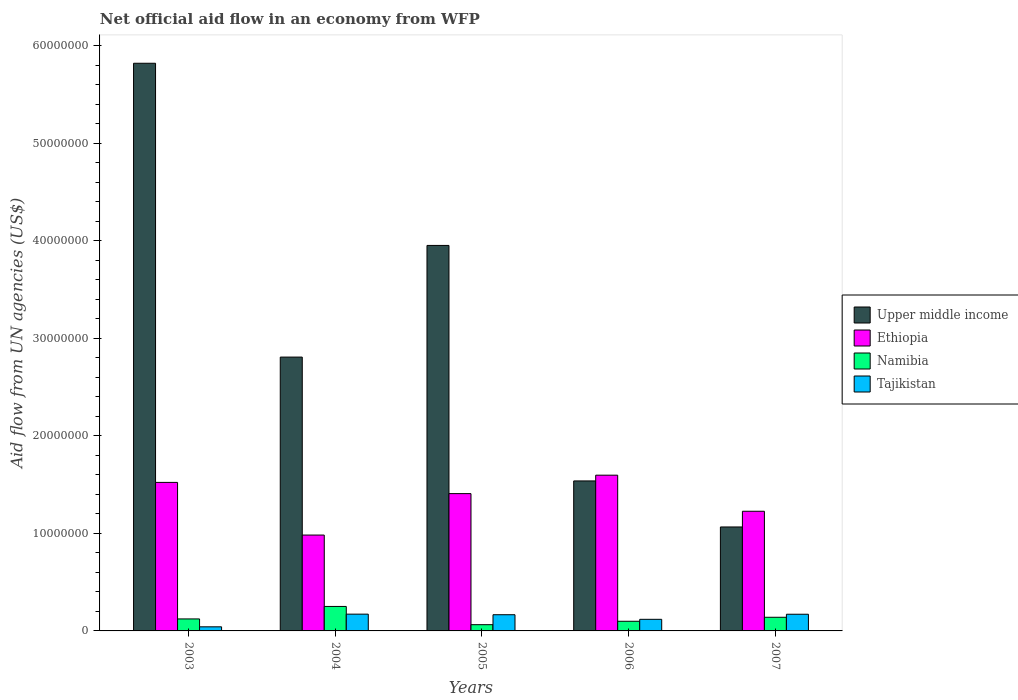Are the number of bars per tick equal to the number of legend labels?
Your answer should be compact. Yes. Are the number of bars on each tick of the X-axis equal?
Your response must be concise. Yes. How many bars are there on the 4th tick from the left?
Provide a succinct answer. 4. How many bars are there on the 2nd tick from the right?
Your answer should be compact. 4. What is the net official aid flow in Tajikistan in 2003?
Provide a short and direct response. 4.20e+05. Across all years, what is the maximum net official aid flow in Upper middle income?
Offer a terse response. 5.82e+07. Across all years, what is the minimum net official aid flow in Upper middle income?
Provide a succinct answer. 1.07e+07. In which year was the net official aid flow in Upper middle income minimum?
Make the answer very short. 2007. What is the total net official aid flow in Tajikistan in the graph?
Provide a succinct answer. 6.70e+06. What is the difference between the net official aid flow in Tajikistan in 2003 and that in 2007?
Your response must be concise. -1.29e+06. What is the difference between the net official aid flow in Upper middle income in 2003 and the net official aid flow in Tajikistan in 2005?
Your response must be concise. 5.66e+07. What is the average net official aid flow in Tajikistan per year?
Your response must be concise. 1.34e+06. In the year 2003, what is the difference between the net official aid flow in Tajikistan and net official aid flow in Ethiopia?
Give a very brief answer. -1.48e+07. What is the ratio of the net official aid flow in Namibia in 2004 to that in 2007?
Your answer should be very brief. 1.79. Is the net official aid flow in Ethiopia in 2005 less than that in 2007?
Your answer should be compact. No. Is the difference between the net official aid flow in Tajikistan in 2005 and 2007 greater than the difference between the net official aid flow in Ethiopia in 2005 and 2007?
Your answer should be very brief. No. What is the difference between the highest and the second highest net official aid flow in Ethiopia?
Your answer should be very brief. 7.40e+05. What is the difference between the highest and the lowest net official aid flow in Tajikistan?
Your answer should be compact. 1.30e+06. In how many years, is the net official aid flow in Upper middle income greater than the average net official aid flow in Upper middle income taken over all years?
Provide a succinct answer. 2. Is the sum of the net official aid flow in Namibia in 2005 and 2006 greater than the maximum net official aid flow in Ethiopia across all years?
Provide a succinct answer. No. Is it the case that in every year, the sum of the net official aid flow in Upper middle income and net official aid flow in Tajikistan is greater than the sum of net official aid flow in Ethiopia and net official aid flow in Namibia?
Keep it short and to the point. No. What does the 1st bar from the left in 2007 represents?
Ensure brevity in your answer.  Upper middle income. What does the 1st bar from the right in 2005 represents?
Your response must be concise. Tajikistan. How many bars are there?
Your response must be concise. 20. Does the graph contain any zero values?
Make the answer very short. No. How are the legend labels stacked?
Give a very brief answer. Vertical. What is the title of the graph?
Your response must be concise. Net official aid flow in an economy from WFP. Does "South Africa" appear as one of the legend labels in the graph?
Your response must be concise. No. What is the label or title of the X-axis?
Offer a terse response. Years. What is the label or title of the Y-axis?
Offer a terse response. Aid flow from UN agencies (US$). What is the Aid flow from UN agencies (US$) of Upper middle income in 2003?
Your answer should be compact. 5.82e+07. What is the Aid flow from UN agencies (US$) of Ethiopia in 2003?
Give a very brief answer. 1.52e+07. What is the Aid flow from UN agencies (US$) of Namibia in 2003?
Provide a succinct answer. 1.23e+06. What is the Aid flow from UN agencies (US$) in Upper middle income in 2004?
Your response must be concise. 2.81e+07. What is the Aid flow from UN agencies (US$) in Ethiopia in 2004?
Make the answer very short. 9.83e+06. What is the Aid flow from UN agencies (US$) of Namibia in 2004?
Provide a succinct answer. 2.51e+06. What is the Aid flow from UN agencies (US$) in Tajikistan in 2004?
Offer a terse response. 1.72e+06. What is the Aid flow from UN agencies (US$) of Upper middle income in 2005?
Offer a very short reply. 3.95e+07. What is the Aid flow from UN agencies (US$) of Ethiopia in 2005?
Make the answer very short. 1.41e+07. What is the Aid flow from UN agencies (US$) in Namibia in 2005?
Make the answer very short. 6.40e+05. What is the Aid flow from UN agencies (US$) of Tajikistan in 2005?
Your response must be concise. 1.66e+06. What is the Aid flow from UN agencies (US$) in Upper middle income in 2006?
Your response must be concise. 1.54e+07. What is the Aid flow from UN agencies (US$) in Ethiopia in 2006?
Your answer should be compact. 1.60e+07. What is the Aid flow from UN agencies (US$) in Namibia in 2006?
Provide a succinct answer. 9.90e+05. What is the Aid flow from UN agencies (US$) of Tajikistan in 2006?
Provide a succinct answer. 1.19e+06. What is the Aid flow from UN agencies (US$) of Upper middle income in 2007?
Ensure brevity in your answer.  1.07e+07. What is the Aid flow from UN agencies (US$) in Ethiopia in 2007?
Make the answer very short. 1.23e+07. What is the Aid flow from UN agencies (US$) in Namibia in 2007?
Your answer should be very brief. 1.40e+06. What is the Aid flow from UN agencies (US$) in Tajikistan in 2007?
Provide a succinct answer. 1.71e+06. Across all years, what is the maximum Aid flow from UN agencies (US$) of Upper middle income?
Ensure brevity in your answer.  5.82e+07. Across all years, what is the maximum Aid flow from UN agencies (US$) of Ethiopia?
Provide a short and direct response. 1.60e+07. Across all years, what is the maximum Aid flow from UN agencies (US$) in Namibia?
Make the answer very short. 2.51e+06. Across all years, what is the maximum Aid flow from UN agencies (US$) of Tajikistan?
Your response must be concise. 1.72e+06. Across all years, what is the minimum Aid flow from UN agencies (US$) in Upper middle income?
Give a very brief answer. 1.07e+07. Across all years, what is the minimum Aid flow from UN agencies (US$) in Ethiopia?
Keep it short and to the point. 9.83e+06. Across all years, what is the minimum Aid flow from UN agencies (US$) in Namibia?
Provide a succinct answer. 6.40e+05. What is the total Aid flow from UN agencies (US$) in Upper middle income in the graph?
Offer a very short reply. 1.52e+08. What is the total Aid flow from UN agencies (US$) of Ethiopia in the graph?
Offer a terse response. 6.74e+07. What is the total Aid flow from UN agencies (US$) of Namibia in the graph?
Make the answer very short. 6.77e+06. What is the total Aid flow from UN agencies (US$) of Tajikistan in the graph?
Offer a terse response. 6.70e+06. What is the difference between the Aid flow from UN agencies (US$) in Upper middle income in 2003 and that in 2004?
Your answer should be very brief. 3.01e+07. What is the difference between the Aid flow from UN agencies (US$) in Ethiopia in 2003 and that in 2004?
Provide a short and direct response. 5.40e+06. What is the difference between the Aid flow from UN agencies (US$) of Namibia in 2003 and that in 2004?
Offer a terse response. -1.28e+06. What is the difference between the Aid flow from UN agencies (US$) of Tajikistan in 2003 and that in 2004?
Make the answer very short. -1.30e+06. What is the difference between the Aid flow from UN agencies (US$) in Upper middle income in 2003 and that in 2005?
Make the answer very short. 1.87e+07. What is the difference between the Aid flow from UN agencies (US$) of Ethiopia in 2003 and that in 2005?
Your answer should be compact. 1.15e+06. What is the difference between the Aid flow from UN agencies (US$) of Namibia in 2003 and that in 2005?
Offer a very short reply. 5.90e+05. What is the difference between the Aid flow from UN agencies (US$) in Tajikistan in 2003 and that in 2005?
Offer a terse response. -1.24e+06. What is the difference between the Aid flow from UN agencies (US$) in Upper middle income in 2003 and that in 2006?
Offer a terse response. 4.28e+07. What is the difference between the Aid flow from UN agencies (US$) in Ethiopia in 2003 and that in 2006?
Your response must be concise. -7.40e+05. What is the difference between the Aid flow from UN agencies (US$) in Namibia in 2003 and that in 2006?
Offer a terse response. 2.40e+05. What is the difference between the Aid flow from UN agencies (US$) of Tajikistan in 2003 and that in 2006?
Offer a terse response. -7.70e+05. What is the difference between the Aid flow from UN agencies (US$) in Upper middle income in 2003 and that in 2007?
Provide a short and direct response. 4.76e+07. What is the difference between the Aid flow from UN agencies (US$) in Ethiopia in 2003 and that in 2007?
Make the answer very short. 2.96e+06. What is the difference between the Aid flow from UN agencies (US$) of Namibia in 2003 and that in 2007?
Keep it short and to the point. -1.70e+05. What is the difference between the Aid flow from UN agencies (US$) of Tajikistan in 2003 and that in 2007?
Provide a short and direct response. -1.29e+06. What is the difference between the Aid flow from UN agencies (US$) of Upper middle income in 2004 and that in 2005?
Provide a short and direct response. -1.14e+07. What is the difference between the Aid flow from UN agencies (US$) of Ethiopia in 2004 and that in 2005?
Make the answer very short. -4.25e+06. What is the difference between the Aid flow from UN agencies (US$) in Namibia in 2004 and that in 2005?
Your answer should be very brief. 1.87e+06. What is the difference between the Aid flow from UN agencies (US$) in Upper middle income in 2004 and that in 2006?
Give a very brief answer. 1.27e+07. What is the difference between the Aid flow from UN agencies (US$) in Ethiopia in 2004 and that in 2006?
Offer a terse response. -6.14e+06. What is the difference between the Aid flow from UN agencies (US$) in Namibia in 2004 and that in 2006?
Your answer should be compact. 1.52e+06. What is the difference between the Aid flow from UN agencies (US$) of Tajikistan in 2004 and that in 2006?
Your answer should be very brief. 5.30e+05. What is the difference between the Aid flow from UN agencies (US$) in Upper middle income in 2004 and that in 2007?
Your response must be concise. 1.74e+07. What is the difference between the Aid flow from UN agencies (US$) of Ethiopia in 2004 and that in 2007?
Your response must be concise. -2.44e+06. What is the difference between the Aid flow from UN agencies (US$) in Namibia in 2004 and that in 2007?
Keep it short and to the point. 1.11e+06. What is the difference between the Aid flow from UN agencies (US$) in Upper middle income in 2005 and that in 2006?
Offer a very short reply. 2.42e+07. What is the difference between the Aid flow from UN agencies (US$) in Ethiopia in 2005 and that in 2006?
Offer a terse response. -1.89e+06. What is the difference between the Aid flow from UN agencies (US$) of Namibia in 2005 and that in 2006?
Provide a short and direct response. -3.50e+05. What is the difference between the Aid flow from UN agencies (US$) in Tajikistan in 2005 and that in 2006?
Your answer should be compact. 4.70e+05. What is the difference between the Aid flow from UN agencies (US$) of Upper middle income in 2005 and that in 2007?
Your response must be concise. 2.89e+07. What is the difference between the Aid flow from UN agencies (US$) of Ethiopia in 2005 and that in 2007?
Provide a succinct answer. 1.81e+06. What is the difference between the Aid flow from UN agencies (US$) of Namibia in 2005 and that in 2007?
Your answer should be very brief. -7.60e+05. What is the difference between the Aid flow from UN agencies (US$) in Tajikistan in 2005 and that in 2007?
Your answer should be very brief. -5.00e+04. What is the difference between the Aid flow from UN agencies (US$) in Upper middle income in 2006 and that in 2007?
Provide a short and direct response. 4.72e+06. What is the difference between the Aid flow from UN agencies (US$) of Ethiopia in 2006 and that in 2007?
Provide a succinct answer. 3.70e+06. What is the difference between the Aid flow from UN agencies (US$) of Namibia in 2006 and that in 2007?
Provide a short and direct response. -4.10e+05. What is the difference between the Aid flow from UN agencies (US$) of Tajikistan in 2006 and that in 2007?
Make the answer very short. -5.20e+05. What is the difference between the Aid flow from UN agencies (US$) of Upper middle income in 2003 and the Aid flow from UN agencies (US$) of Ethiopia in 2004?
Offer a very short reply. 4.84e+07. What is the difference between the Aid flow from UN agencies (US$) of Upper middle income in 2003 and the Aid flow from UN agencies (US$) of Namibia in 2004?
Give a very brief answer. 5.57e+07. What is the difference between the Aid flow from UN agencies (US$) in Upper middle income in 2003 and the Aid flow from UN agencies (US$) in Tajikistan in 2004?
Provide a succinct answer. 5.65e+07. What is the difference between the Aid flow from UN agencies (US$) in Ethiopia in 2003 and the Aid flow from UN agencies (US$) in Namibia in 2004?
Give a very brief answer. 1.27e+07. What is the difference between the Aid flow from UN agencies (US$) in Ethiopia in 2003 and the Aid flow from UN agencies (US$) in Tajikistan in 2004?
Keep it short and to the point. 1.35e+07. What is the difference between the Aid flow from UN agencies (US$) in Namibia in 2003 and the Aid flow from UN agencies (US$) in Tajikistan in 2004?
Give a very brief answer. -4.90e+05. What is the difference between the Aid flow from UN agencies (US$) of Upper middle income in 2003 and the Aid flow from UN agencies (US$) of Ethiopia in 2005?
Your answer should be very brief. 4.41e+07. What is the difference between the Aid flow from UN agencies (US$) in Upper middle income in 2003 and the Aid flow from UN agencies (US$) in Namibia in 2005?
Offer a very short reply. 5.76e+07. What is the difference between the Aid flow from UN agencies (US$) of Upper middle income in 2003 and the Aid flow from UN agencies (US$) of Tajikistan in 2005?
Your answer should be compact. 5.66e+07. What is the difference between the Aid flow from UN agencies (US$) of Ethiopia in 2003 and the Aid flow from UN agencies (US$) of Namibia in 2005?
Ensure brevity in your answer.  1.46e+07. What is the difference between the Aid flow from UN agencies (US$) of Ethiopia in 2003 and the Aid flow from UN agencies (US$) of Tajikistan in 2005?
Offer a terse response. 1.36e+07. What is the difference between the Aid flow from UN agencies (US$) in Namibia in 2003 and the Aid flow from UN agencies (US$) in Tajikistan in 2005?
Make the answer very short. -4.30e+05. What is the difference between the Aid flow from UN agencies (US$) of Upper middle income in 2003 and the Aid flow from UN agencies (US$) of Ethiopia in 2006?
Provide a short and direct response. 4.22e+07. What is the difference between the Aid flow from UN agencies (US$) in Upper middle income in 2003 and the Aid flow from UN agencies (US$) in Namibia in 2006?
Make the answer very short. 5.72e+07. What is the difference between the Aid flow from UN agencies (US$) in Upper middle income in 2003 and the Aid flow from UN agencies (US$) in Tajikistan in 2006?
Offer a terse response. 5.70e+07. What is the difference between the Aid flow from UN agencies (US$) of Ethiopia in 2003 and the Aid flow from UN agencies (US$) of Namibia in 2006?
Your answer should be compact. 1.42e+07. What is the difference between the Aid flow from UN agencies (US$) in Ethiopia in 2003 and the Aid flow from UN agencies (US$) in Tajikistan in 2006?
Offer a terse response. 1.40e+07. What is the difference between the Aid flow from UN agencies (US$) in Namibia in 2003 and the Aid flow from UN agencies (US$) in Tajikistan in 2006?
Give a very brief answer. 4.00e+04. What is the difference between the Aid flow from UN agencies (US$) in Upper middle income in 2003 and the Aid flow from UN agencies (US$) in Ethiopia in 2007?
Provide a short and direct response. 4.59e+07. What is the difference between the Aid flow from UN agencies (US$) of Upper middle income in 2003 and the Aid flow from UN agencies (US$) of Namibia in 2007?
Provide a succinct answer. 5.68e+07. What is the difference between the Aid flow from UN agencies (US$) of Upper middle income in 2003 and the Aid flow from UN agencies (US$) of Tajikistan in 2007?
Make the answer very short. 5.65e+07. What is the difference between the Aid flow from UN agencies (US$) in Ethiopia in 2003 and the Aid flow from UN agencies (US$) in Namibia in 2007?
Give a very brief answer. 1.38e+07. What is the difference between the Aid flow from UN agencies (US$) of Ethiopia in 2003 and the Aid flow from UN agencies (US$) of Tajikistan in 2007?
Provide a succinct answer. 1.35e+07. What is the difference between the Aid flow from UN agencies (US$) in Namibia in 2003 and the Aid flow from UN agencies (US$) in Tajikistan in 2007?
Your answer should be very brief. -4.80e+05. What is the difference between the Aid flow from UN agencies (US$) in Upper middle income in 2004 and the Aid flow from UN agencies (US$) in Ethiopia in 2005?
Offer a very short reply. 1.40e+07. What is the difference between the Aid flow from UN agencies (US$) of Upper middle income in 2004 and the Aid flow from UN agencies (US$) of Namibia in 2005?
Offer a terse response. 2.74e+07. What is the difference between the Aid flow from UN agencies (US$) of Upper middle income in 2004 and the Aid flow from UN agencies (US$) of Tajikistan in 2005?
Give a very brief answer. 2.64e+07. What is the difference between the Aid flow from UN agencies (US$) in Ethiopia in 2004 and the Aid flow from UN agencies (US$) in Namibia in 2005?
Make the answer very short. 9.19e+06. What is the difference between the Aid flow from UN agencies (US$) in Ethiopia in 2004 and the Aid flow from UN agencies (US$) in Tajikistan in 2005?
Ensure brevity in your answer.  8.17e+06. What is the difference between the Aid flow from UN agencies (US$) of Namibia in 2004 and the Aid flow from UN agencies (US$) of Tajikistan in 2005?
Provide a succinct answer. 8.50e+05. What is the difference between the Aid flow from UN agencies (US$) in Upper middle income in 2004 and the Aid flow from UN agencies (US$) in Ethiopia in 2006?
Offer a terse response. 1.21e+07. What is the difference between the Aid flow from UN agencies (US$) in Upper middle income in 2004 and the Aid flow from UN agencies (US$) in Namibia in 2006?
Provide a short and direct response. 2.71e+07. What is the difference between the Aid flow from UN agencies (US$) of Upper middle income in 2004 and the Aid flow from UN agencies (US$) of Tajikistan in 2006?
Your response must be concise. 2.69e+07. What is the difference between the Aid flow from UN agencies (US$) in Ethiopia in 2004 and the Aid flow from UN agencies (US$) in Namibia in 2006?
Ensure brevity in your answer.  8.84e+06. What is the difference between the Aid flow from UN agencies (US$) in Ethiopia in 2004 and the Aid flow from UN agencies (US$) in Tajikistan in 2006?
Give a very brief answer. 8.64e+06. What is the difference between the Aid flow from UN agencies (US$) of Namibia in 2004 and the Aid flow from UN agencies (US$) of Tajikistan in 2006?
Make the answer very short. 1.32e+06. What is the difference between the Aid flow from UN agencies (US$) in Upper middle income in 2004 and the Aid flow from UN agencies (US$) in Ethiopia in 2007?
Provide a succinct answer. 1.58e+07. What is the difference between the Aid flow from UN agencies (US$) in Upper middle income in 2004 and the Aid flow from UN agencies (US$) in Namibia in 2007?
Give a very brief answer. 2.67e+07. What is the difference between the Aid flow from UN agencies (US$) of Upper middle income in 2004 and the Aid flow from UN agencies (US$) of Tajikistan in 2007?
Provide a short and direct response. 2.64e+07. What is the difference between the Aid flow from UN agencies (US$) of Ethiopia in 2004 and the Aid flow from UN agencies (US$) of Namibia in 2007?
Keep it short and to the point. 8.43e+06. What is the difference between the Aid flow from UN agencies (US$) of Ethiopia in 2004 and the Aid flow from UN agencies (US$) of Tajikistan in 2007?
Provide a short and direct response. 8.12e+06. What is the difference between the Aid flow from UN agencies (US$) in Namibia in 2004 and the Aid flow from UN agencies (US$) in Tajikistan in 2007?
Ensure brevity in your answer.  8.00e+05. What is the difference between the Aid flow from UN agencies (US$) of Upper middle income in 2005 and the Aid flow from UN agencies (US$) of Ethiopia in 2006?
Your answer should be compact. 2.36e+07. What is the difference between the Aid flow from UN agencies (US$) of Upper middle income in 2005 and the Aid flow from UN agencies (US$) of Namibia in 2006?
Give a very brief answer. 3.85e+07. What is the difference between the Aid flow from UN agencies (US$) of Upper middle income in 2005 and the Aid flow from UN agencies (US$) of Tajikistan in 2006?
Provide a succinct answer. 3.83e+07. What is the difference between the Aid flow from UN agencies (US$) in Ethiopia in 2005 and the Aid flow from UN agencies (US$) in Namibia in 2006?
Your answer should be compact. 1.31e+07. What is the difference between the Aid flow from UN agencies (US$) in Ethiopia in 2005 and the Aid flow from UN agencies (US$) in Tajikistan in 2006?
Your response must be concise. 1.29e+07. What is the difference between the Aid flow from UN agencies (US$) of Namibia in 2005 and the Aid flow from UN agencies (US$) of Tajikistan in 2006?
Make the answer very short. -5.50e+05. What is the difference between the Aid flow from UN agencies (US$) of Upper middle income in 2005 and the Aid flow from UN agencies (US$) of Ethiopia in 2007?
Ensure brevity in your answer.  2.73e+07. What is the difference between the Aid flow from UN agencies (US$) in Upper middle income in 2005 and the Aid flow from UN agencies (US$) in Namibia in 2007?
Your response must be concise. 3.81e+07. What is the difference between the Aid flow from UN agencies (US$) of Upper middle income in 2005 and the Aid flow from UN agencies (US$) of Tajikistan in 2007?
Ensure brevity in your answer.  3.78e+07. What is the difference between the Aid flow from UN agencies (US$) in Ethiopia in 2005 and the Aid flow from UN agencies (US$) in Namibia in 2007?
Your answer should be very brief. 1.27e+07. What is the difference between the Aid flow from UN agencies (US$) in Ethiopia in 2005 and the Aid flow from UN agencies (US$) in Tajikistan in 2007?
Your answer should be compact. 1.24e+07. What is the difference between the Aid flow from UN agencies (US$) in Namibia in 2005 and the Aid flow from UN agencies (US$) in Tajikistan in 2007?
Your answer should be compact. -1.07e+06. What is the difference between the Aid flow from UN agencies (US$) in Upper middle income in 2006 and the Aid flow from UN agencies (US$) in Ethiopia in 2007?
Ensure brevity in your answer.  3.11e+06. What is the difference between the Aid flow from UN agencies (US$) in Upper middle income in 2006 and the Aid flow from UN agencies (US$) in Namibia in 2007?
Provide a short and direct response. 1.40e+07. What is the difference between the Aid flow from UN agencies (US$) of Upper middle income in 2006 and the Aid flow from UN agencies (US$) of Tajikistan in 2007?
Keep it short and to the point. 1.37e+07. What is the difference between the Aid flow from UN agencies (US$) in Ethiopia in 2006 and the Aid flow from UN agencies (US$) in Namibia in 2007?
Offer a terse response. 1.46e+07. What is the difference between the Aid flow from UN agencies (US$) of Ethiopia in 2006 and the Aid flow from UN agencies (US$) of Tajikistan in 2007?
Your answer should be compact. 1.43e+07. What is the difference between the Aid flow from UN agencies (US$) in Namibia in 2006 and the Aid flow from UN agencies (US$) in Tajikistan in 2007?
Offer a very short reply. -7.20e+05. What is the average Aid flow from UN agencies (US$) in Upper middle income per year?
Keep it short and to the point. 3.04e+07. What is the average Aid flow from UN agencies (US$) of Ethiopia per year?
Provide a short and direct response. 1.35e+07. What is the average Aid flow from UN agencies (US$) of Namibia per year?
Ensure brevity in your answer.  1.35e+06. What is the average Aid flow from UN agencies (US$) in Tajikistan per year?
Keep it short and to the point. 1.34e+06. In the year 2003, what is the difference between the Aid flow from UN agencies (US$) of Upper middle income and Aid flow from UN agencies (US$) of Ethiopia?
Ensure brevity in your answer.  4.30e+07. In the year 2003, what is the difference between the Aid flow from UN agencies (US$) of Upper middle income and Aid flow from UN agencies (US$) of Namibia?
Your response must be concise. 5.70e+07. In the year 2003, what is the difference between the Aid flow from UN agencies (US$) of Upper middle income and Aid flow from UN agencies (US$) of Tajikistan?
Your response must be concise. 5.78e+07. In the year 2003, what is the difference between the Aid flow from UN agencies (US$) of Ethiopia and Aid flow from UN agencies (US$) of Namibia?
Give a very brief answer. 1.40e+07. In the year 2003, what is the difference between the Aid flow from UN agencies (US$) in Ethiopia and Aid flow from UN agencies (US$) in Tajikistan?
Offer a very short reply. 1.48e+07. In the year 2003, what is the difference between the Aid flow from UN agencies (US$) of Namibia and Aid flow from UN agencies (US$) of Tajikistan?
Your response must be concise. 8.10e+05. In the year 2004, what is the difference between the Aid flow from UN agencies (US$) of Upper middle income and Aid flow from UN agencies (US$) of Ethiopia?
Your answer should be very brief. 1.82e+07. In the year 2004, what is the difference between the Aid flow from UN agencies (US$) in Upper middle income and Aid flow from UN agencies (US$) in Namibia?
Provide a short and direct response. 2.56e+07. In the year 2004, what is the difference between the Aid flow from UN agencies (US$) in Upper middle income and Aid flow from UN agencies (US$) in Tajikistan?
Give a very brief answer. 2.64e+07. In the year 2004, what is the difference between the Aid flow from UN agencies (US$) in Ethiopia and Aid flow from UN agencies (US$) in Namibia?
Keep it short and to the point. 7.32e+06. In the year 2004, what is the difference between the Aid flow from UN agencies (US$) of Ethiopia and Aid flow from UN agencies (US$) of Tajikistan?
Offer a terse response. 8.11e+06. In the year 2004, what is the difference between the Aid flow from UN agencies (US$) of Namibia and Aid flow from UN agencies (US$) of Tajikistan?
Make the answer very short. 7.90e+05. In the year 2005, what is the difference between the Aid flow from UN agencies (US$) of Upper middle income and Aid flow from UN agencies (US$) of Ethiopia?
Give a very brief answer. 2.54e+07. In the year 2005, what is the difference between the Aid flow from UN agencies (US$) in Upper middle income and Aid flow from UN agencies (US$) in Namibia?
Ensure brevity in your answer.  3.89e+07. In the year 2005, what is the difference between the Aid flow from UN agencies (US$) in Upper middle income and Aid flow from UN agencies (US$) in Tajikistan?
Give a very brief answer. 3.79e+07. In the year 2005, what is the difference between the Aid flow from UN agencies (US$) of Ethiopia and Aid flow from UN agencies (US$) of Namibia?
Your answer should be compact. 1.34e+07. In the year 2005, what is the difference between the Aid flow from UN agencies (US$) of Ethiopia and Aid flow from UN agencies (US$) of Tajikistan?
Ensure brevity in your answer.  1.24e+07. In the year 2005, what is the difference between the Aid flow from UN agencies (US$) in Namibia and Aid flow from UN agencies (US$) in Tajikistan?
Provide a succinct answer. -1.02e+06. In the year 2006, what is the difference between the Aid flow from UN agencies (US$) in Upper middle income and Aid flow from UN agencies (US$) in Ethiopia?
Provide a succinct answer. -5.90e+05. In the year 2006, what is the difference between the Aid flow from UN agencies (US$) in Upper middle income and Aid flow from UN agencies (US$) in Namibia?
Give a very brief answer. 1.44e+07. In the year 2006, what is the difference between the Aid flow from UN agencies (US$) of Upper middle income and Aid flow from UN agencies (US$) of Tajikistan?
Make the answer very short. 1.42e+07. In the year 2006, what is the difference between the Aid flow from UN agencies (US$) of Ethiopia and Aid flow from UN agencies (US$) of Namibia?
Offer a terse response. 1.50e+07. In the year 2006, what is the difference between the Aid flow from UN agencies (US$) of Ethiopia and Aid flow from UN agencies (US$) of Tajikistan?
Offer a terse response. 1.48e+07. In the year 2007, what is the difference between the Aid flow from UN agencies (US$) in Upper middle income and Aid flow from UN agencies (US$) in Ethiopia?
Offer a very short reply. -1.61e+06. In the year 2007, what is the difference between the Aid flow from UN agencies (US$) of Upper middle income and Aid flow from UN agencies (US$) of Namibia?
Make the answer very short. 9.26e+06. In the year 2007, what is the difference between the Aid flow from UN agencies (US$) in Upper middle income and Aid flow from UN agencies (US$) in Tajikistan?
Your answer should be very brief. 8.95e+06. In the year 2007, what is the difference between the Aid flow from UN agencies (US$) of Ethiopia and Aid flow from UN agencies (US$) of Namibia?
Give a very brief answer. 1.09e+07. In the year 2007, what is the difference between the Aid flow from UN agencies (US$) in Ethiopia and Aid flow from UN agencies (US$) in Tajikistan?
Your answer should be very brief. 1.06e+07. In the year 2007, what is the difference between the Aid flow from UN agencies (US$) of Namibia and Aid flow from UN agencies (US$) of Tajikistan?
Provide a succinct answer. -3.10e+05. What is the ratio of the Aid flow from UN agencies (US$) of Upper middle income in 2003 to that in 2004?
Your response must be concise. 2.07. What is the ratio of the Aid flow from UN agencies (US$) in Ethiopia in 2003 to that in 2004?
Provide a succinct answer. 1.55. What is the ratio of the Aid flow from UN agencies (US$) of Namibia in 2003 to that in 2004?
Your answer should be compact. 0.49. What is the ratio of the Aid flow from UN agencies (US$) of Tajikistan in 2003 to that in 2004?
Provide a short and direct response. 0.24. What is the ratio of the Aid flow from UN agencies (US$) in Upper middle income in 2003 to that in 2005?
Keep it short and to the point. 1.47. What is the ratio of the Aid flow from UN agencies (US$) of Ethiopia in 2003 to that in 2005?
Keep it short and to the point. 1.08. What is the ratio of the Aid flow from UN agencies (US$) in Namibia in 2003 to that in 2005?
Your answer should be very brief. 1.92. What is the ratio of the Aid flow from UN agencies (US$) in Tajikistan in 2003 to that in 2005?
Offer a very short reply. 0.25. What is the ratio of the Aid flow from UN agencies (US$) of Upper middle income in 2003 to that in 2006?
Offer a terse response. 3.78. What is the ratio of the Aid flow from UN agencies (US$) of Ethiopia in 2003 to that in 2006?
Offer a terse response. 0.95. What is the ratio of the Aid flow from UN agencies (US$) in Namibia in 2003 to that in 2006?
Your answer should be very brief. 1.24. What is the ratio of the Aid flow from UN agencies (US$) of Tajikistan in 2003 to that in 2006?
Keep it short and to the point. 0.35. What is the ratio of the Aid flow from UN agencies (US$) of Upper middle income in 2003 to that in 2007?
Your answer should be very brief. 5.46. What is the ratio of the Aid flow from UN agencies (US$) in Ethiopia in 2003 to that in 2007?
Offer a terse response. 1.24. What is the ratio of the Aid flow from UN agencies (US$) of Namibia in 2003 to that in 2007?
Offer a terse response. 0.88. What is the ratio of the Aid flow from UN agencies (US$) of Tajikistan in 2003 to that in 2007?
Ensure brevity in your answer.  0.25. What is the ratio of the Aid flow from UN agencies (US$) of Upper middle income in 2004 to that in 2005?
Your response must be concise. 0.71. What is the ratio of the Aid flow from UN agencies (US$) in Ethiopia in 2004 to that in 2005?
Keep it short and to the point. 0.7. What is the ratio of the Aid flow from UN agencies (US$) of Namibia in 2004 to that in 2005?
Give a very brief answer. 3.92. What is the ratio of the Aid flow from UN agencies (US$) of Tajikistan in 2004 to that in 2005?
Provide a succinct answer. 1.04. What is the ratio of the Aid flow from UN agencies (US$) of Upper middle income in 2004 to that in 2006?
Ensure brevity in your answer.  1.83. What is the ratio of the Aid flow from UN agencies (US$) of Ethiopia in 2004 to that in 2006?
Provide a short and direct response. 0.62. What is the ratio of the Aid flow from UN agencies (US$) of Namibia in 2004 to that in 2006?
Your answer should be compact. 2.54. What is the ratio of the Aid flow from UN agencies (US$) in Tajikistan in 2004 to that in 2006?
Your answer should be very brief. 1.45. What is the ratio of the Aid flow from UN agencies (US$) in Upper middle income in 2004 to that in 2007?
Offer a very short reply. 2.63. What is the ratio of the Aid flow from UN agencies (US$) of Ethiopia in 2004 to that in 2007?
Your answer should be compact. 0.8. What is the ratio of the Aid flow from UN agencies (US$) in Namibia in 2004 to that in 2007?
Offer a very short reply. 1.79. What is the ratio of the Aid flow from UN agencies (US$) of Upper middle income in 2005 to that in 2006?
Your answer should be compact. 2.57. What is the ratio of the Aid flow from UN agencies (US$) in Ethiopia in 2005 to that in 2006?
Keep it short and to the point. 0.88. What is the ratio of the Aid flow from UN agencies (US$) in Namibia in 2005 to that in 2006?
Give a very brief answer. 0.65. What is the ratio of the Aid flow from UN agencies (US$) of Tajikistan in 2005 to that in 2006?
Give a very brief answer. 1.4. What is the ratio of the Aid flow from UN agencies (US$) of Upper middle income in 2005 to that in 2007?
Provide a succinct answer. 3.71. What is the ratio of the Aid flow from UN agencies (US$) of Ethiopia in 2005 to that in 2007?
Your answer should be compact. 1.15. What is the ratio of the Aid flow from UN agencies (US$) in Namibia in 2005 to that in 2007?
Offer a terse response. 0.46. What is the ratio of the Aid flow from UN agencies (US$) in Tajikistan in 2005 to that in 2007?
Your answer should be very brief. 0.97. What is the ratio of the Aid flow from UN agencies (US$) in Upper middle income in 2006 to that in 2007?
Provide a succinct answer. 1.44. What is the ratio of the Aid flow from UN agencies (US$) of Ethiopia in 2006 to that in 2007?
Your answer should be very brief. 1.3. What is the ratio of the Aid flow from UN agencies (US$) of Namibia in 2006 to that in 2007?
Make the answer very short. 0.71. What is the ratio of the Aid flow from UN agencies (US$) of Tajikistan in 2006 to that in 2007?
Make the answer very short. 0.7. What is the difference between the highest and the second highest Aid flow from UN agencies (US$) in Upper middle income?
Ensure brevity in your answer.  1.87e+07. What is the difference between the highest and the second highest Aid flow from UN agencies (US$) of Ethiopia?
Your response must be concise. 7.40e+05. What is the difference between the highest and the second highest Aid flow from UN agencies (US$) of Namibia?
Provide a succinct answer. 1.11e+06. What is the difference between the highest and the lowest Aid flow from UN agencies (US$) in Upper middle income?
Your response must be concise. 4.76e+07. What is the difference between the highest and the lowest Aid flow from UN agencies (US$) of Ethiopia?
Provide a succinct answer. 6.14e+06. What is the difference between the highest and the lowest Aid flow from UN agencies (US$) in Namibia?
Offer a terse response. 1.87e+06. What is the difference between the highest and the lowest Aid flow from UN agencies (US$) in Tajikistan?
Offer a terse response. 1.30e+06. 